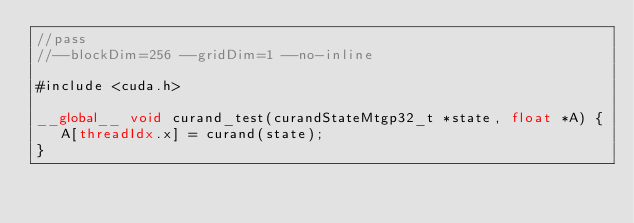Convert code to text. <code><loc_0><loc_0><loc_500><loc_500><_Cuda_>//pass
//--blockDim=256 --gridDim=1 --no-inline

#include <cuda.h>

__global__ void curand_test(curandStateMtgp32_t *state, float *A) {
   A[threadIdx.x] = curand(state);
}
</code> 